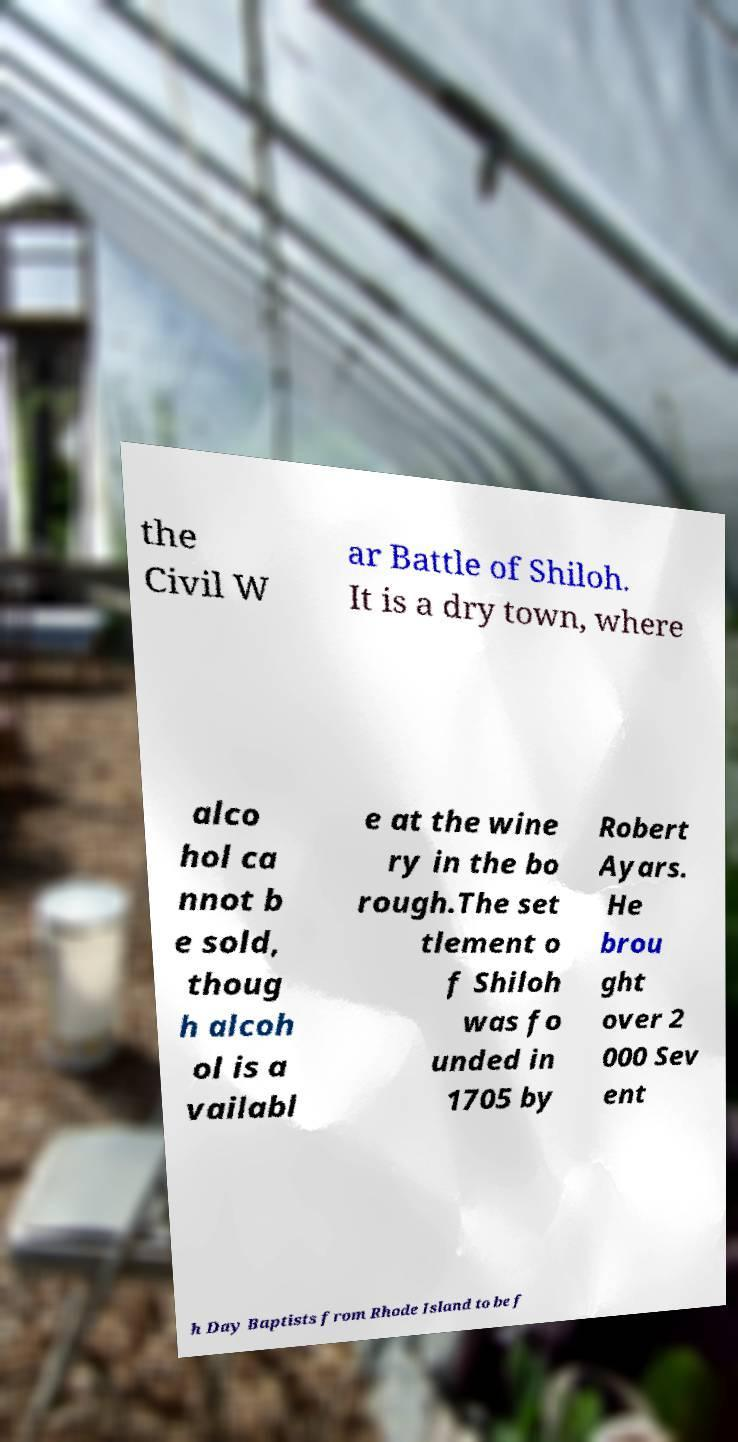Could you extract and type out the text from this image? the Civil W ar Battle of Shiloh. It is a dry town, where alco hol ca nnot b e sold, thoug h alcoh ol is a vailabl e at the wine ry in the bo rough.The set tlement o f Shiloh was fo unded in 1705 by Robert Ayars. He brou ght over 2 000 Sev ent h Day Baptists from Rhode Island to be f 